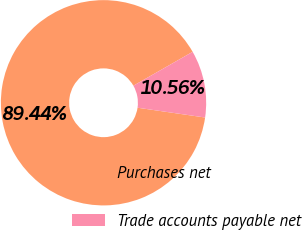<chart> <loc_0><loc_0><loc_500><loc_500><pie_chart><fcel>Purchases net<fcel>Trade accounts payable net<nl><fcel>89.44%<fcel>10.56%<nl></chart> 